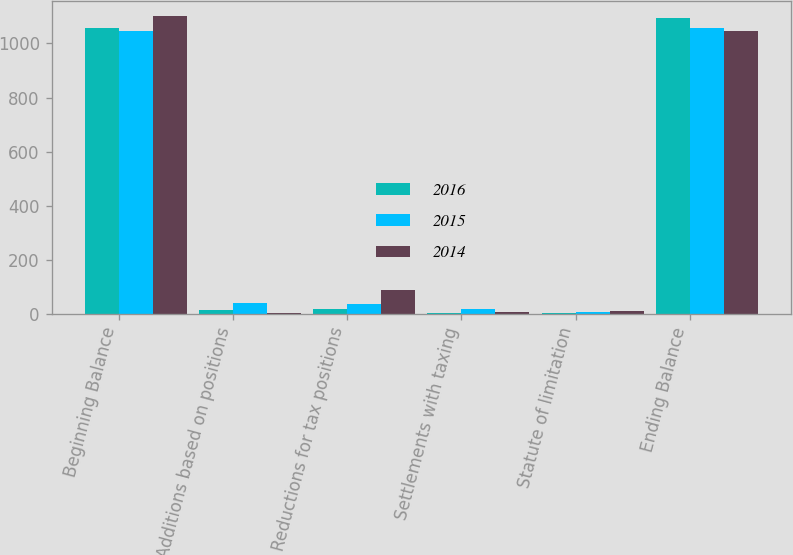Convert chart to OTSL. <chart><loc_0><loc_0><loc_500><loc_500><stacked_bar_chart><ecel><fcel>Beginning Balance<fcel>Additions based on positions<fcel>Reductions for tax positions<fcel>Settlements with taxing<fcel>Statute of limitation<fcel>Ending Balance<nl><fcel>2016<fcel>1056<fcel>14<fcel>17<fcel>3<fcel>2<fcel>1095<nl><fcel>2015<fcel>1047<fcel>38<fcel>36<fcel>18<fcel>7<fcel>1056<nl><fcel>2014<fcel>1102<fcel>3<fcel>87<fcel>5<fcel>10<fcel>1047<nl></chart> 